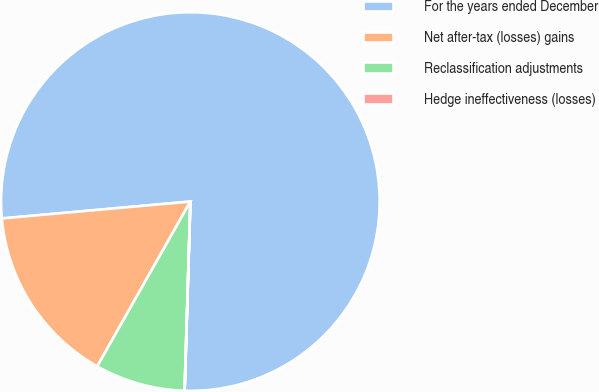Convert chart. <chart><loc_0><loc_0><loc_500><loc_500><pie_chart><fcel>For the years ended December<fcel>Net after-tax (losses) gains<fcel>Reclassification adjustments<fcel>Hedge ineffectiveness (losses)<nl><fcel>76.91%<fcel>15.39%<fcel>7.7%<fcel>0.01%<nl></chart> 